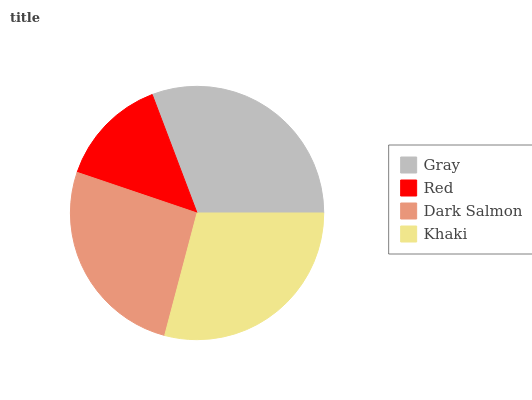Is Red the minimum?
Answer yes or no. Yes. Is Gray the maximum?
Answer yes or no. Yes. Is Dark Salmon the minimum?
Answer yes or no. No. Is Dark Salmon the maximum?
Answer yes or no. No. Is Dark Salmon greater than Red?
Answer yes or no. Yes. Is Red less than Dark Salmon?
Answer yes or no. Yes. Is Red greater than Dark Salmon?
Answer yes or no. No. Is Dark Salmon less than Red?
Answer yes or no. No. Is Khaki the high median?
Answer yes or no. Yes. Is Dark Salmon the low median?
Answer yes or no. Yes. Is Gray the high median?
Answer yes or no. No. Is Gray the low median?
Answer yes or no. No. 